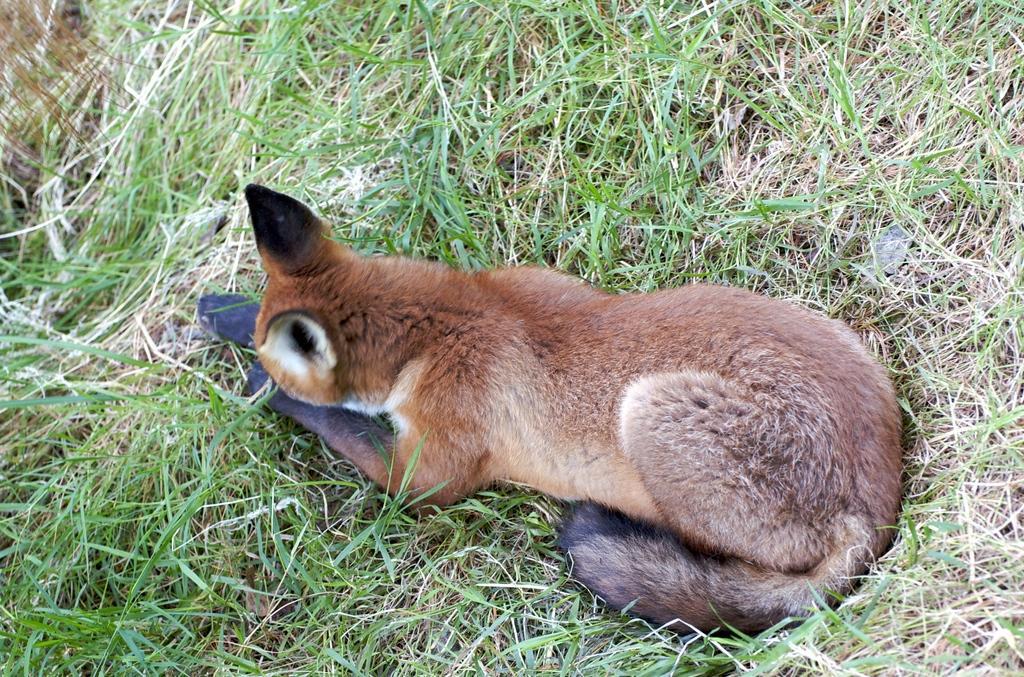Describe this image in one or two sentences. In this image an animal is sitting on the grass. 